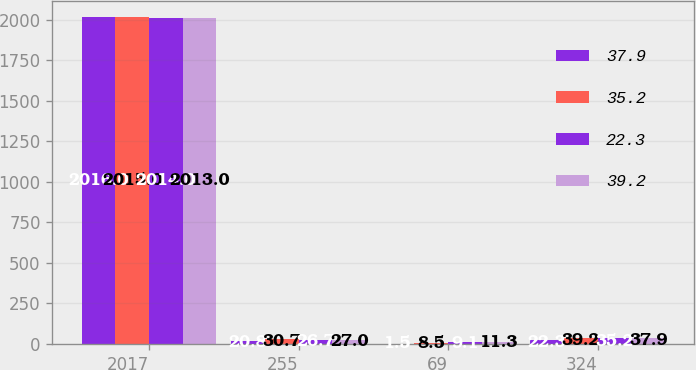Convert chart to OTSL. <chart><loc_0><loc_0><loc_500><loc_500><stacked_bar_chart><ecel><fcel>2017<fcel>255<fcel>69<fcel>324<nl><fcel>37.9<fcel>2016<fcel>20.8<fcel>1.5<fcel>22.3<nl><fcel>35.2<fcel>2015<fcel>30.7<fcel>8.5<fcel>39.2<nl><fcel>22.3<fcel>2014<fcel>26.7<fcel>9.1<fcel>35.2<nl><fcel>39.2<fcel>2013<fcel>27<fcel>11.3<fcel>37.9<nl></chart> 